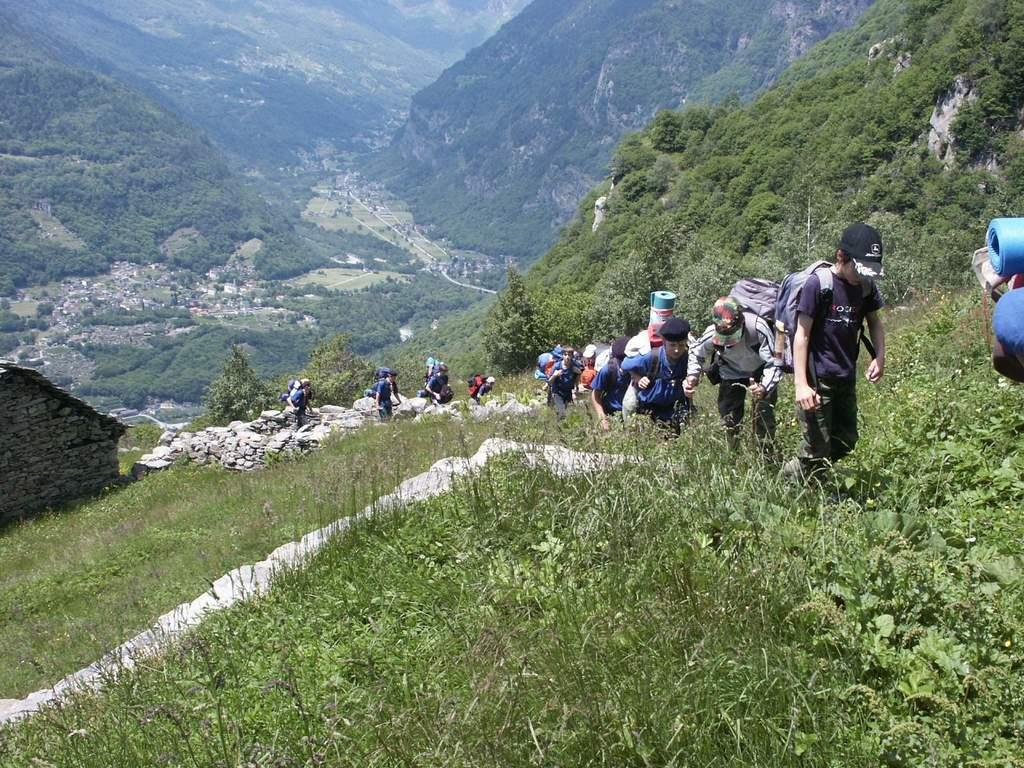How many people are in the image? There is a group of people in the image. What are the people doing in the image? The people are walking on a path. What can be seen behind the people in the image? There are trees visible behind the people. What is visible in the background of the image? There are hills visible in the background. What type of ship can be seen sailing in the background of the image? There is no ship visible in the image; it features a group of people walking on a path with trees and hills in the background. 